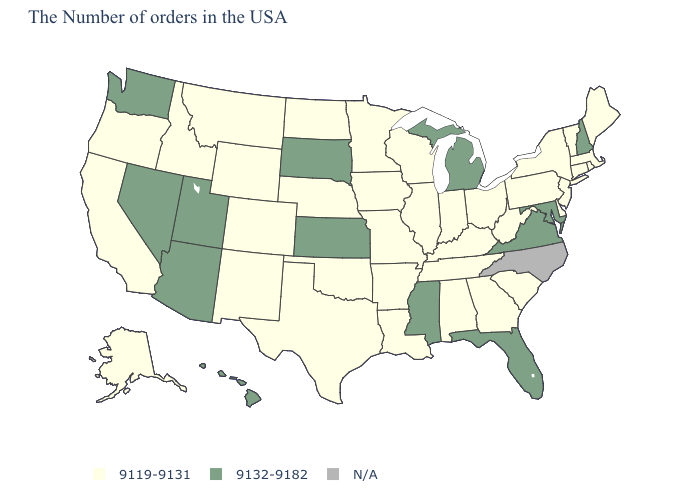What is the value of Vermont?
Give a very brief answer. 9119-9131. What is the value of California?
Short answer required. 9119-9131. Which states have the lowest value in the West?
Write a very short answer. Wyoming, Colorado, New Mexico, Montana, Idaho, California, Oregon, Alaska. Which states have the highest value in the USA?
Short answer required. New Hampshire, Maryland, Virginia, Florida, Michigan, Mississippi, Kansas, South Dakota, Utah, Arizona, Nevada, Washington, Hawaii. Among the states that border Delaware , does New Jersey have the highest value?
Concise answer only. No. Does the map have missing data?
Keep it brief. Yes. Name the states that have a value in the range 9119-9131?
Short answer required. Maine, Massachusetts, Rhode Island, Vermont, Connecticut, New York, New Jersey, Delaware, Pennsylvania, South Carolina, West Virginia, Ohio, Georgia, Kentucky, Indiana, Alabama, Tennessee, Wisconsin, Illinois, Louisiana, Missouri, Arkansas, Minnesota, Iowa, Nebraska, Oklahoma, Texas, North Dakota, Wyoming, Colorado, New Mexico, Montana, Idaho, California, Oregon, Alaska. Among the states that border South Carolina , which have the highest value?
Keep it brief. Georgia. What is the value of Pennsylvania?
Be succinct. 9119-9131. Does the map have missing data?
Be succinct. Yes. Which states have the highest value in the USA?
Quick response, please. New Hampshire, Maryland, Virginia, Florida, Michigan, Mississippi, Kansas, South Dakota, Utah, Arizona, Nevada, Washington, Hawaii. Name the states that have a value in the range N/A?
Quick response, please. North Carolina. What is the highest value in the USA?
Concise answer only. 9132-9182. Does the map have missing data?
Answer briefly. Yes. Name the states that have a value in the range N/A?
Give a very brief answer. North Carolina. 